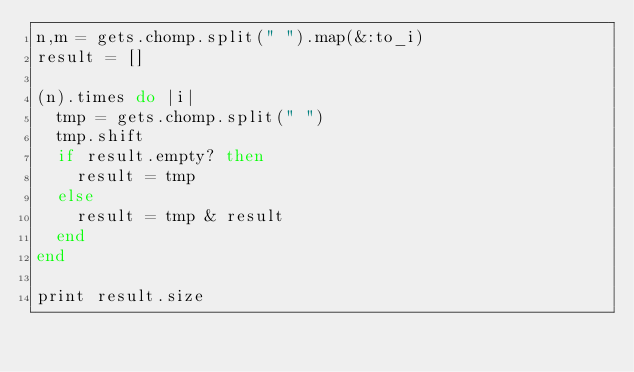<code> <loc_0><loc_0><loc_500><loc_500><_Ruby_>n,m = gets.chomp.split(" ").map(&:to_i)
result = []

(n).times do |i|
  tmp = gets.chomp.split(" ")
  tmp.shift
  if result.empty? then
    result = tmp
  else
    result = tmp & result
  end
end

print result.size
</code> 